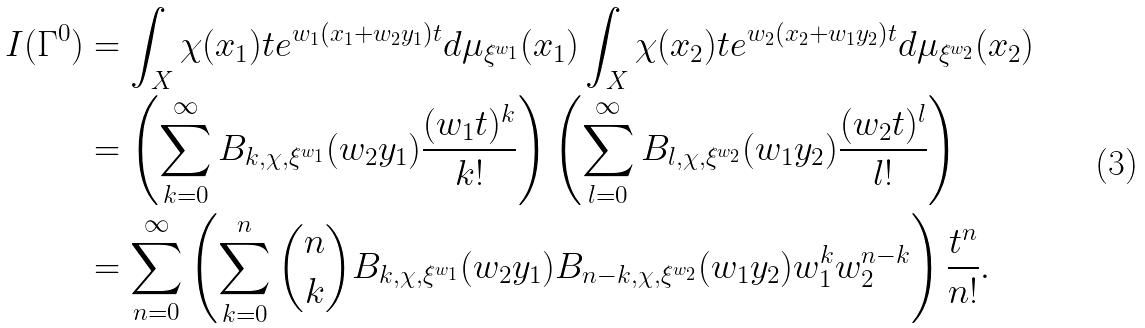<formula> <loc_0><loc_0><loc_500><loc_500>I ( \Gamma ^ { 0 } ) & = \int _ { X } \chi ( x _ { 1 } ) t e ^ { w _ { 1 } ( x _ { 1 } + w _ { 2 } y _ { 1 } ) t } d \mu _ { \xi ^ { w _ { 1 } } } ( x _ { 1 } ) \int _ { X } \chi ( x _ { 2 } ) t e ^ { w _ { 2 } ( x _ { 2 } + w _ { 1 } y _ { 2 } ) t } d \mu _ { \xi ^ { w _ { 2 } } } ( x _ { 2 } ) \\ & = \left ( \sum _ { k = 0 } ^ { \infty } B _ { k , \chi , \xi ^ { w _ { 1 } } } ( w _ { 2 } y _ { 1 } ) \frac { ( w _ { 1 } t ) ^ { k } } { k ! } \right ) \left ( \sum _ { l = 0 } ^ { \infty } B _ { l , \chi , \xi ^ { w _ { 2 } } } ( w _ { 1 } y _ { 2 } ) \frac { ( w _ { 2 } t ) ^ { l } } { l ! } \right ) \\ & = \sum _ { n = 0 } ^ { \infty } \left ( \sum _ { k = 0 } ^ { n } \binom { n } { k } B _ { k , \chi , \xi ^ { w _ { 1 } } } ( w _ { 2 } y _ { 1 } ) B _ { n - k , \chi , \xi ^ { w _ { 2 } } } ( w _ { 1 } y _ { 2 } ) w _ { 1 } ^ { k } w _ { 2 } ^ { n - k } \right ) \frac { t ^ { n } } { n ! } .</formula> 